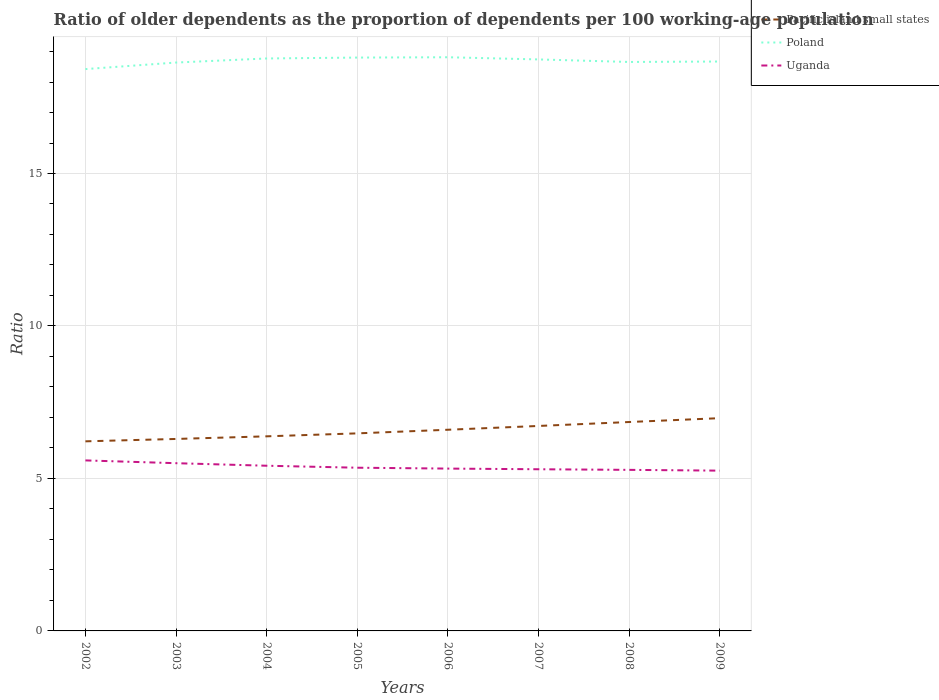How many different coloured lines are there?
Ensure brevity in your answer.  3. Does the line corresponding to Poland intersect with the line corresponding to Uganda?
Make the answer very short. No. Is the number of lines equal to the number of legend labels?
Give a very brief answer. Yes. Across all years, what is the maximum age dependency ratio(old) in Pacific island small states?
Offer a terse response. 6.22. What is the total age dependency ratio(old) in Pacific island small states in the graph?
Your answer should be compact. -0.76. What is the difference between the highest and the second highest age dependency ratio(old) in Pacific island small states?
Keep it short and to the point. 0.76. What is the difference between the highest and the lowest age dependency ratio(old) in Pacific island small states?
Provide a short and direct response. 4. How many lines are there?
Your answer should be compact. 3. How many years are there in the graph?
Your answer should be compact. 8. Are the values on the major ticks of Y-axis written in scientific E-notation?
Your response must be concise. No. Where does the legend appear in the graph?
Give a very brief answer. Top right. How many legend labels are there?
Keep it short and to the point. 3. How are the legend labels stacked?
Give a very brief answer. Vertical. What is the title of the graph?
Your answer should be very brief. Ratio of older dependents as the proportion of dependents per 100 working-age population. What is the label or title of the X-axis?
Your response must be concise. Years. What is the label or title of the Y-axis?
Give a very brief answer. Ratio. What is the Ratio in Pacific island small states in 2002?
Your answer should be compact. 6.22. What is the Ratio in Poland in 2002?
Provide a short and direct response. 18.42. What is the Ratio of Uganda in 2002?
Make the answer very short. 5.59. What is the Ratio of Pacific island small states in 2003?
Offer a very short reply. 6.3. What is the Ratio of Poland in 2003?
Keep it short and to the point. 18.64. What is the Ratio in Uganda in 2003?
Offer a terse response. 5.5. What is the Ratio in Pacific island small states in 2004?
Your answer should be very brief. 6.38. What is the Ratio of Poland in 2004?
Provide a short and direct response. 18.77. What is the Ratio in Uganda in 2004?
Your answer should be compact. 5.42. What is the Ratio of Pacific island small states in 2005?
Keep it short and to the point. 6.48. What is the Ratio of Poland in 2005?
Offer a terse response. 18.8. What is the Ratio of Uganda in 2005?
Keep it short and to the point. 5.35. What is the Ratio of Pacific island small states in 2006?
Your response must be concise. 6.6. What is the Ratio in Poland in 2006?
Ensure brevity in your answer.  18.81. What is the Ratio of Uganda in 2006?
Provide a succinct answer. 5.32. What is the Ratio in Pacific island small states in 2007?
Your answer should be compact. 6.72. What is the Ratio in Poland in 2007?
Make the answer very short. 18.74. What is the Ratio in Uganda in 2007?
Give a very brief answer. 5.3. What is the Ratio of Pacific island small states in 2008?
Keep it short and to the point. 6.85. What is the Ratio of Poland in 2008?
Provide a short and direct response. 18.66. What is the Ratio of Uganda in 2008?
Give a very brief answer. 5.28. What is the Ratio of Pacific island small states in 2009?
Your response must be concise. 6.98. What is the Ratio in Poland in 2009?
Keep it short and to the point. 18.67. What is the Ratio of Uganda in 2009?
Give a very brief answer. 5.26. Across all years, what is the maximum Ratio of Pacific island small states?
Offer a terse response. 6.98. Across all years, what is the maximum Ratio of Poland?
Your response must be concise. 18.81. Across all years, what is the maximum Ratio of Uganda?
Provide a succinct answer. 5.59. Across all years, what is the minimum Ratio of Pacific island small states?
Give a very brief answer. 6.22. Across all years, what is the minimum Ratio in Poland?
Your answer should be compact. 18.42. Across all years, what is the minimum Ratio of Uganda?
Give a very brief answer. 5.26. What is the total Ratio of Pacific island small states in the graph?
Your answer should be compact. 52.52. What is the total Ratio of Poland in the graph?
Give a very brief answer. 149.52. What is the total Ratio of Uganda in the graph?
Provide a succinct answer. 43.02. What is the difference between the Ratio of Pacific island small states in 2002 and that in 2003?
Give a very brief answer. -0.08. What is the difference between the Ratio of Poland in 2002 and that in 2003?
Offer a very short reply. -0.21. What is the difference between the Ratio of Uganda in 2002 and that in 2003?
Offer a very short reply. 0.09. What is the difference between the Ratio of Pacific island small states in 2002 and that in 2004?
Offer a very short reply. -0.16. What is the difference between the Ratio of Poland in 2002 and that in 2004?
Your answer should be very brief. -0.35. What is the difference between the Ratio in Uganda in 2002 and that in 2004?
Keep it short and to the point. 0.17. What is the difference between the Ratio in Pacific island small states in 2002 and that in 2005?
Ensure brevity in your answer.  -0.26. What is the difference between the Ratio in Poland in 2002 and that in 2005?
Keep it short and to the point. -0.38. What is the difference between the Ratio in Uganda in 2002 and that in 2005?
Your answer should be very brief. 0.24. What is the difference between the Ratio of Pacific island small states in 2002 and that in 2006?
Your answer should be compact. -0.38. What is the difference between the Ratio of Poland in 2002 and that in 2006?
Your response must be concise. -0.39. What is the difference between the Ratio in Uganda in 2002 and that in 2006?
Your response must be concise. 0.27. What is the difference between the Ratio of Pacific island small states in 2002 and that in 2007?
Provide a short and direct response. -0.5. What is the difference between the Ratio of Poland in 2002 and that in 2007?
Ensure brevity in your answer.  -0.32. What is the difference between the Ratio of Uganda in 2002 and that in 2007?
Keep it short and to the point. 0.29. What is the difference between the Ratio in Pacific island small states in 2002 and that in 2008?
Provide a short and direct response. -0.63. What is the difference between the Ratio of Poland in 2002 and that in 2008?
Provide a succinct answer. -0.23. What is the difference between the Ratio of Uganda in 2002 and that in 2008?
Keep it short and to the point. 0.31. What is the difference between the Ratio of Pacific island small states in 2002 and that in 2009?
Offer a very short reply. -0.76. What is the difference between the Ratio in Poland in 2002 and that in 2009?
Your answer should be compact. -0.25. What is the difference between the Ratio of Uganda in 2002 and that in 2009?
Your answer should be very brief. 0.34. What is the difference between the Ratio in Pacific island small states in 2003 and that in 2004?
Offer a very short reply. -0.09. What is the difference between the Ratio in Poland in 2003 and that in 2004?
Offer a terse response. -0.13. What is the difference between the Ratio of Uganda in 2003 and that in 2004?
Your answer should be very brief. 0.08. What is the difference between the Ratio of Pacific island small states in 2003 and that in 2005?
Your response must be concise. -0.18. What is the difference between the Ratio in Poland in 2003 and that in 2005?
Ensure brevity in your answer.  -0.16. What is the difference between the Ratio in Uganda in 2003 and that in 2005?
Provide a succinct answer. 0.15. What is the difference between the Ratio of Pacific island small states in 2003 and that in 2006?
Provide a short and direct response. -0.3. What is the difference between the Ratio in Poland in 2003 and that in 2006?
Ensure brevity in your answer.  -0.17. What is the difference between the Ratio in Uganda in 2003 and that in 2006?
Provide a succinct answer. 0.18. What is the difference between the Ratio in Pacific island small states in 2003 and that in 2007?
Offer a very short reply. -0.43. What is the difference between the Ratio in Poland in 2003 and that in 2007?
Give a very brief answer. -0.1. What is the difference between the Ratio in Uganda in 2003 and that in 2007?
Offer a terse response. 0.2. What is the difference between the Ratio of Pacific island small states in 2003 and that in 2008?
Keep it short and to the point. -0.55. What is the difference between the Ratio in Poland in 2003 and that in 2008?
Keep it short and to the point. -0.02. What is the difference between the Ratio in Uganda in 2003 and that in 2008?
Your answer should be compact. 0.22. What is the difference between the Ratio in Pacific island small states in 2003 and that in 2009?
Provide a short and direct response. -0.68. What is the difference between the Ratio of Poland in 2003 and that in 2009?
Make the answer very short. -0.03. What is the difference between the Ratio in Uganda in 2003 and that in 2009?
Offer a terse response. 0.24. What is the difference between the Ratio of Pacific island small states in 2004 and that in 2005?
Provide a short and direct response. -0.1. What is the difference between the Ratio of Poland in 2004 and that in 2005?
Make the answer very short. -0.03. What is the difference between the Ratio in Uganda in 2004 and that in 2005?
Offer a terse response. 0.06. What is the difference between the Ratio of Pacific island small states in 2004 and that in 2006?
Give a very brief answer. -0.22. What is the difference between the Ratio in Poland in 2004 and that in 2006?
Keep it short and to the point. -0.04. What is the difference between the Ratio in Uganda in 2004 and that in 2006?
Offer a very short reply. 0.09. What is the difference between the Ratio of Pacific island small states in 2004 and that in 2007?
Offer a terse response. -0.34. What is the difference between the Ratio of Poland in 2004 and that in 2007?
Your answer should be very brief. 0.03. What is the difference between the Ratio in Uganda in 2004 and that in 2007?
Your answer should be very brief. 0.12. What is the difference between the Ratio in Pacific island small states in 2004 and that in 2008?
Offer a terse response. -0.47. What is the difference between the Ratio of Poland in 2004 and that in 2008?
Offer a terse response. 0.11. What is the difference between the Ratio of Uganda in 2004 and that in 2008?
Provide a succinct answer. 0.14. What is the difference between the Ratio in Pacific island small states in 2004 and that in 2009?
Offer a terse response. -0.6. What is the difference between the Ratio of Poland in 2004 and that in 2009?
Offer a terse response. 0.1. What is the difference between the Ratio in Uganda in 2004 and that in 2009?
Provide a short and direct response. 0.16. What is the difference between the Ratio of Pacific island small states in 2005 and that in 2006?
Offer a very short reply. -0.12. What is the difference between the Ratio in Poland in 2005 and that in 2006?
Your answer should be very brief. -0.01. What is the difference between the Ratio of Uganda in 2005 and that in 2006?
Your response must be concise. 0.03. What is the difference between the Ratio of Pacific island small states in 2005 and that in 2007?
Your answer should be very brief. -0.24. What is the difference between the Ratio in Poland in 2005 and that in 2007?
Ensure brevity in your answer.  0.06. What is the difference between the Ratio in Uganda in 2005 and that in 2007?
Offer a very short reply. 0.05. What is the difference between the Ratio of Pacific island small states in 2005 and that in 2008?
Offer a very short reply. -0.37. What is the difference between the Ratio of Poland in 2005 and that in 2008?
Give a very brief answer. 0.14. What is the difference between the Ratio of Uganda in 2005 and that in 2008?
Give a very brief answer. 0.07. What is the difference between the Ratio of Pacific island small states in 2005 and that in 2009?
Provide a succinct answer. -0.5. What is the difference between the Ratio of Poland in 2005 and that in 2009?
Provide a short and direct response. 0.13. What is the difference between the Ratio of Uganda in 2005 and that in 2009?
Provide a succinct answer. 0.1. What is the difference between the Ratio in Pacific island small states in 2006 and that in 2007?
Provide a succinct answer. -0.12. What is the difference between the Ratio of Poland in 2006 and that in 2007?
Give a very brief answer. 0.07. What is the difference between the Ratio in Uganda in 2006 and that in 2007?
Your answer should be very brief. 0.02. What is the difference between the Ratio of Pacific island small states in 2006 and that in 2008?
Make the answer very short. -0.25. What is the difference between the Ratio in Poland in 2006 and that in 2008?
Provide a succinct answer. 0.15. What is the difference between the Ratio in Uganda in 2006 and that in 2008?
Provide a succinct answer. 0.04. What is the difference between the Ratio in Pacific island small states in 2006 and that in 2009?
Provide a short and direct response. -0.38. What is the difference between the Ratio of Poland in 2006 and that in 2009?
Provide a short and direct response. 0.14. What is the difference between the Ratio of Uganda in 2006 and that in 2009?
Ensure brevity in your answer.  0.07. What is the difference between the Ratio in Pacific island small states in 2007 and that in 2008?
Your answer should be compact. -0.13. What is the difference between the Ratio in Poland in 2007 and that in 2008?
Your answer should be compact. 0.08. What is the difference between the Ratio of Pacific island small states in 2007 and that in 2009?
Keep it short and to the point. -0.26. What is the difference between the Ratio of Poland in 2007 and that in 2009?
Ensure brevity in your answer.  0.07. What is the difference between the Ratio in Uganda in 2007 and that in 2009?
Your answer should be compact. 0.05. What is the difference between the Ratio of Pacific island small states in 2008 and that in 2009?
Give a very brief answer. -0.13. What is the difference between the Ratio of Poland in 2008 and that in 2009?
Keep it short and to the point. -0.01. What is the difference between the Ratio in Uganda in 2008 and that in 2009?
Keep it short and to the point. 0.03. What is the difference between the Ratio in Pacific island small states in 2002 and the Ratio in Poland in 2003?
Your answer should be compact. -12.42. What is the difference between the Ratio in Pacific island small states in 2002 and the Ratio in Uganda in 2003?
Your response must be concise. 0.72. What is the difference between the Ratio of Poland in 2002 and the Ratio of Uganda in 2003?
Your response must be concise. 12.92. What is the difference between the Ratio of Pacific island small states in 2002 and the Ratio of Poland in 2004?
Keep it short and to the point. -12.55. What is the difference between the Ratio of Pacific island small states in 2002 and the Ratio of Uganda in 2004?
Your answer should be very brief. 0.8. What is the difference between the Ratio of Poland in 2002 and the Ratio of Uganda in 2004?
Keep it short and to the point. 13.01. What is the difference between the Ratio of Pacific island small states in 2002 and the Ratio of Poland in 2005?
Your response must be concise. -12.58. What is the difference between the Ratio of Pacific island small states in 2002 and the Ratio of Uganda in 2005?
Ensure brevity in your answer.  0.87. What is the difference between the Ratio of Poland in 2002 and the Ratio of Uganda in 2005?
Your response must be concise. 13.07. What is the difference between the Ratio of Pacific island small states in 2002 and the Ratio of Poland in 2006?
Your answer should be compact. -12.6. What is the difference between the Ratio of Pacific island small states in 2002 and the Ratio of Uganda in 2006?
Your answer should be very brief. 0.89. What is the difference between the Ratio of Poland in 2002 and the Ratio of Uganda in 2006?
Keep it short and to the point. 13.1. What is the difference between the Ratio in Pacific island small states in 2002 and the Ratio in Poland in 2007?
Give a very brief answer. -12.52. What is the difference between the Ratio in Pacific island small states in 2002 and the Ratio in Uganda in 2007?
Make the answer very short. 0.92. What is the difference between the Ratio of Poland in 2002 and the Ratio of Uganda in 2007?
Keep it short and to the point. 13.12. What is the difference between the Ratio of Pacific island small states in 2002 and the Ratio of Poland in 2008?
Offer a very short reply. -12.44. What is the difference between the Ratio in Pacific island small states in 2002 and the Ratio in Uganda in 2008?
Keep it short and to the point. 0.94. What is the difference between the Ratio in Poland in 2002 and the Ratio in Uganda in 2008?
Make the answer very short. 13.14. What is the difference between the Ratio in Pacific island small states in 2002 and the Ratio in Poland in 2009?
Offer a very short reply. -12.45. What is the difference between the Ratio in Pacific island small states in 2002 and the Ratio in Uganda in 2009?
Make the answer very short. 0.96. What is the difference between the Ratio in Poland in 2002 and the Ratio in Uganda in 2009?
Keep it short and to the point. 13.17. What is the difference between the Ratio of Pacific island small states in 2003 and the Ratio of Poland in 2004?
Keep it short and to the point. -12.48. What is the difference between the Ratio in Pacific island small states in 2003 and the Ratio in Uganda in 2004?
Make the answer very short. 0.88. What is the difference between the Ratio in Poland in 2003 and the Ratio in Uganda in 2004?
Your answer should be very brief. 13.22. What is the difference between the Ratio in Pacific island small states in 2003 and the Ratio in Poland in 2005?
Your answer should be compact. -12.51. What is the difference between the Ratio in Pacific island small states in 2003 and the Ratio in Uganda in 2005?
Keep it short and to the point. 0.94. What is the difference between the Ratio of Poland in 2003 and the Ratio of Uganda in 2005?
Your answer should be very brief. 13.29. What is the difference between the Ratio in Pacific island small states in 2003 and the Ratio in Poland in 2006?
Make the answer very short. -12.52. What is the difference between the Ratio of Pacific island small states in 2003 and the Ratio of Uganda in 2006?
Give a very brief answer. 0.97. What is the difference between the Ratio of Poland in 2003 and the Ratio of Uganda in 2006?
Give a very brief answer. 13.32. What is the difference between the Ratio of Pacific island small states in 2003 and the Ratio of Poland in 2007?
Your answer should be compact. -12.45. What is the difference between the Ratio of Poland in 2003 and the Ratio of Uganda in 2007?
Your answer should be very brief. 13.34. What is the difference between the Ratio of Pacific island small states in 2003 and the Ratio of Poland in 2008?
Your response must be concise. -12.36. What is the difference between the Ratio of Pacific island small states in 2003 and the Ratio of Uganda in 2008?
Provide a short and direct response. 1.01. What is the difference between the Ratio of Poland in 2003 and the Ratio of Uganda in 2008?
Your response must be concise. 13.36. What is the difference between the Ratio in Pacific island small states in 2003 and the Ratio in Poland in 2009?
Provide a succinct answer. -12.38. What is the difference between the Ratio of Pacific island small states in 2003 and the Ratio of Uganda in 2009?
Provide a succinct answer. 1.04. What is the difference between the Ratio of Poland in 2003 and the Ratio of Uganda in 2009?
Give a very brief answer. 13.38. What is the difference between the Ratio in Pacific island small states in 2004 and the Ratio in Poland in 2005?
Ensure brevity in your answer.  -12.42. What is the difference between the Ratio in Pacific island small states in 2004 and the Ratio in Uganda in 2005?
Your answer should be compact. 1.03. What is the difference between the Ratio of Poland in 2004 and the Ratio of Uganda in 2005?
Make the answer very short. 13.42. What is the difference between the Ratio in Pacific island small states in 2004 and the Ratio in Poland in 2006?
Your answer should be compact. -12.43. What is the difference between the Ratio of Pacific island small states in 2004 and the Ratio of Uganda in 2006?
Provide a short and direct response. 1.06. What is the difference between the Ratio in Poland in 2004 and the Ratio in Uganda in 2006?
Offer a very short reply. 13.45. What is the difference between the Ratio of Pacific island small states in 2004 and the Ratio of Poland in 2007?
Make the answer very short. -12.36. What is the difference between the Ratio in Pacific island small states in 2004 and the Ratio in Uganda in 2007?
Your response must be concise. 1.08. What is the difference between the Ratio of Poland in 2004 and the Ratio of Uganda in 2007?
Your response must be concise. 13.47. What is the difference between the Ratio of Pacific island small states in 2004 and the Ratio of Poland in 2008?
Your answer should be very brief. -12.28. What is the difference between the Ratio in Pacific island small states in 2004 and the Ratio in Uganda in 2008?
Provide a short and direct response. 1.1. What is the difference between the Ratio in Poland in 2004 and the Ratio in Uganda in 2008?
Your response must be concise. 13.49. What is the difference between the Ratio in Pacific island small states in 2004 and the Ratio in Poland in 2009?
Offer a terse response. -12.29. What is the difference between the Ratio of Pacific island small states in 2004 and the Ratio of Uganda in 2009?
Keep it short and to the point. 1.13. What is the difference between the Ratio in Poland in 2004 and the Ratio in Uganda in 2009?
Your response must be concise. 13.52. What is the difference between the Ratio in Pacific island small states in 2005 and the Ratio in Poland in 2006?
Your response must be concise. -12.33. What is the difference between the Ratio in Pacific island small states in 2005 and the Ratio in Uganda in 2006?
Make the answer very short. 1.15. What is the difference between the Ratio of Poland in 2005 and the Ratio of Uganda in 2006?
Your response must be concise. 13.48. What is the difference between the Ratio in Pacific island small states in 2005 and the Ratio in Poland in 2007?
Your answer should be compact. -12.26. What is the difference between the Ratio in Pacific island small states in 2005 and the Ratio in Uganda in 2007?
Keep it short and to the point. 1.18. What is the difference between the Ratio in Poland in 2005 and the Ratio in Uganda in 2007?
Your answer should be compact. 13.5. What is the difference between the Ratio of Pacific island small states in 2005 and the Ratio of Poland in 2008?
Provide a succinct answer. -12.18. What is the difference between the Ratio in Pacific island small states in 2005 and the Ratio in Uganda in 2008?
Give a very brief answer. 1.2. What is the difference between the Ratio in Poland in 2005 and the Ratio in Uganda in 2008?
Offer a very short reply. 13.52. What is the difference between the Ratio in Pacific island small states in 2005 and the Ratio in Poland in 2009?
Your answer should be compact. -12.19. What is the difference between the Ratio of Pacific island small states in 2005 and the Ratio of Uganda in 2009?
Keep it short and to the point. 1.22. What is the difference between the Ratio of Poland in 2005 and the Ratio of Uganda in 2009?
Provide a succinct answer. 13.55. What is the difference between the Ratio of Pacific island small states in 2006 and the Ratio of Poland in 2007?
Provide a succinct answer. -12.14. What is the difference between the Ratio of Pacific island small states in 2006 and the Ratio of Uganda in 2007?
Your answer should be very brief. 1.3. What is the difference between the Ratio in Poland in 2006 and the Ratio in Uganda in 2007?
Keep it short and to the point. 13.51. What is the difference between the Ratio of Pacific island small states in 2006 and the Ratio of Poland in 2008?
Your answer should be very brief. -12.06. What is the difference between the Ratio of Pacific island small states in 2006 and the Ratio of Uganda in 2008?
Keep it short and to the point. 1.32. What is the difference between the Ratio of Poland in 2006 and the Ratio of Uganda in 2008?
Offer a terse response. 13.53. What is the difference between the Ratio in Pacific island small states in 2006 and the Ratio in Poland in 2009?
Give a very brief answer. -12.08. What is the difference between the Ratio of Pacific island small states in 2006 and the Ratio of Uganda in 2009?
Provide a short and direct response. 1.34. What is the difference between the Ratio of Poland in 2006 and the Ratio of Uganda in 2009?
Your answer should be very brief. 13.56. What is the difference between the Ratio in Pacific island small states in 2007 and the Ratio in Poland in 2008?
Provide a short and direct response. -11.94. What is the difference between the Ratio in Pacific island small states in 2007 and the Ratio in Uganda in 2008?
Your answer should be compact. 1.44. What is the difference between the Ratio of Poland in 2007 and the Ratio of Uganda in 2008?
Your answer should be very brief. 13.46. What is the difference between the Ratio of Pacific island small states in 2007 and the Ratio of Poland in 2009?
Offer a terse response. -11.95. What is the difference between the Ratio in Pacific island small states in 2007 and the Ratio in Uganda in 2009?
Provide a short and direct response. 1.47. What is the difference between the Ratio of Poland in 2007 and the Ratio of Uganda in 2009?
Your response must be concise. 13.48. What is the difference between the Ratio of Pacific island small states in 2008 and the Ratio of Poland in 2009?
Make the answer very short. -11.82. What is the difference between the Ratio of Pacific island small states in 2008 and the Ratio of Uganda in 2009?
Your answer should be very brief. 1.59. What is the difference between the Ratio in Poland in 2008 and the Ratio in Uganda in 2009?
Provide a short and direct response. 13.4. What is the average Ratio of Pacific island small states per year?
Your answer should be compact. 6.56. What is the average Ratio in Poland per year?
Keep it short and to the point. 18.69. What is the average Ratio of Uganda per year?
Your answer should be compact. 5.38. In the year 2002, what is the difference between the Ratio of Pacific island small states and Ratio of Poland?
Give a very brief answer. -12.21. In the year 2002, what is the difference between the Ratio in Pacific island small states and Ratio in Uganda?
Make the answer very short. 0.63. In the year 2002, what is the difference between the Ratio of Poland and Ratio of Uganda?
Keep it short and to the point. 12.83. In the year 2003, what is the difference between the Ratio of Pacific island small states and Ratio of Poland?
Your response must be concise. -12.34. In the year 2003, what is the difference between the Ratio in Pacific island small states and Ratio in Uganda?
Your response must be concise. 0.8. In the year 2003, what is the difference between the Ratio in Poland and Ratio in Uganda?
Offer a terse response. 13.14. In the year 2004, what is the difference between the Ratio in Pacific island small states and Ratio in Poland?
Your response must be concise. -12.39. In the year 2004, what is the difference between the Ratio in Pacific island small states and Ratio in Uganda?
Provide a succinct answer. 0.96. In the year 2004, what is the difference between the Ratio of Poland and Ratio of Uganda?
Offer a very short reply. 13.36. In the year 2005, what is the difference between the Ratio of Pacific island small states and Ratio of Poland?
Offer a very short reply. -12.32. In the year 2005, what is the difference between the Ratio of Pacific island small states and Ratio of Uganda?
Your answer should be very brief. 1.13. In the year 2005, what is the difference between the Ratio in Poland and Ratio in Uganda?
Provide a short and direct response. 13.45. In the year 2006, what is the difference between the Ratio of Pacific island small states and Ratio of Poland?
Keep it short and to the point. -12.22. In the year 2006, what is the difference between the Ratio of Pacific island small states and Ratio of Uganda?
Your answer should be compact. 1.27. In the year 2006, what is the difference between the Ratio in Poland and Ratio in Uganda?
Make the answer very short. 13.49. In the year 2007, what is the difference between the Ratio in Pacific island small states and Ratio in Poland?
Your answer should be very brief. -12.02. In the year 2007, what is the difference between the Ratio in Pacific island small states and Ratio in Uganda?
Provide a succinct answer. 1.42. In the year 2007, what is the difference between the Ratio of Poland and Ratio of Uganda?
Provide a short and direct response. 13.44. In the year 2008, what is the difference between the Ratio in Pacific island small states and Ratio in Poland?
Your answer should be compact. -11.81. In the year 2008, what is the difference between the Ratio in Pacific island small states and Ratio in Uganda?
Your answer should be very brief. 1.57. In the year 2008, what is the difference between the Ratio of Poland and Ratio of Uganda?
Your response must be concise. 13.38. In the year 2009, what is the difference between the Ratio in Pacific island small states and Ratio in Poland?
Offer a very short reply. -11.7. In the year 2009, what is the difference between the Ratio of Pacific island small states and Ratio of Uganda?
Provide a succinct answer. 1.72. In the year 2009, what is the difference between the Ratio of Poland and Ratio of Uganda?
Your response must be concise. 13.42. What is the ratio of the Ratio of Pacific island small states in 2002 to that in 2003?
Your answer should be compact. 0.99. What is the ratio of the Ratio of Poland in 2002 to that in 2003?
Your answer should be compact. 0.99. What is the ratio of the Ratio in Uganda in 2002 to that in 2003?
Make the answer very short. 1.02. What is the ratio of the Ratio of Pacific island small states in 2002 to that in 2004?
Offer a very short reply. 0.97. What is the ratio of the Ratio of Poland in 2002 to that in 2004?
Keep it short and to the point. 0.98. What is the ratio of the Ratio of Uganda in 2002 to that in 2004?
Your answer should be very brief. 1.03. What is the ratio of the Ratio of Pacific island small states in 2002 to that in 2005?
Give a very brief answer. 0.96. What is the ratio of the Ratio in Poland in 2002 to that in 2005?
Your answer should be very brief. 0.98. What is the ratio of the Ratio of Uganda in 2002 to that in 2005?
Provide a short and direct response. 1.04. What is the ratio of the Ratio in Pacific island small states in 2002 to that in 2006?
Provide a short and direct response. 0.94. What is the ratio of the Ratio in Poland in 2002 to that in 2006?
Your answer should be very brief. 0.98. What is the ratio of the Ratio in Uganda in 2002 to that in 2006?
Offer a terse response. 1.05. What is the ratio of the Ratio of Pacific island small states in 2002 to that in 2007?
Offer a very short reply. 0.93. What is the ratio of the Ratio in Poland in 2002 to that in 2007?
Make the answer very short. 0.98. What is the ratio of the Ratio in Uganda in 2002 to that in 2007?
Provide a succinct answer. 1.05. What is the ratio of the Ratio of Pacific island small states in 2002 to that in 2008?
Give a very brief answer. 0.91. What is the ratio of the Ratio in Poland in 2002 to that in 2008?
Ensure brevity in your answer.  0.99. What is the ratio of the Ratio in Uganda in 2002 to that in 2008?
Your response must be concise. 1.06. What is the ratio of the Ratio in Pacific island small states in 2002 to that in 2009?
Offer a very short reply. 0.89. What is the ratio of the Ratio of Poland in 2002 to that in 2009?
Make the answer very short. 0.99. What is the ratio of the Ratio of Uganda in 2002 to that in 2009?
Offer a very short reply. 1.06. What is the ratio of the Ratio in Pacific island small states in 2003 to that in 2004?
Your answer should be compact. 0.99. What is the ratio of the Ratio in Uganda in 2003 to that in 2004?
Make the answer very short. 1.02. What is the ratio of the Ratio of Pacific island small states in 2003 to that in 2005?
Your response must be concise. 0.97. What is the ratio of the Ratio of Uganda in 2003 to that in 2005?
Your answer should be very brief. 1.03. What is the ratio of the Ratio of Pacific island small states in 2003 to that in 2006?
Your answer should be compact. 0.95. What is the ratio of the Ratio of Uganda in 2003 to that in 2006?
Offer a terse response. 1.03. What is the ratio of the Ratio in Pacific island small states in 2003 to that in 2007?
Offer a terse response. 0.94. What is the ratio of the Ratio in Poland in 2003 to that in 2007?
Provide a short and direct response. 0.99. What is the ratio of the Ratio of Uganda in 2003 to that in 2007?
Provide a short and direct response. 1.04. What is the ratio of the Ratio in Pacific island small states in 2003 to that in 2008?
Offer a very short reply. 0.92. What is the ratio of the Ratio in Uganda in 2003 to that in 2008?
Offer a terse response. 1.04. What is the ratio of the Ratio in Pacific island small states in 2003 to that in 2009?
Provide a short and direct response. 0.9. What is the ratio of the Ratio of Poland in 2003 to that in 2009?
Give a very brief answer. 1. What is the ratio of the Ratio in Uganda in 2003 to that in 2009?
Make the answer very short. 1.05. What is the ratio of the Ratio in Poland in 2004 to that in 2005?
Make the answer very short. 1. What is the ratio of the Ratio in Uganda in 2004 to that in 2005?
Your answer should be very brief. 1.01. What is the ratio of the Ratio in Pacific island small states in 2004 to that in 2006?
Offer a terse response. 0.97. What is the ratio of the Ratio in Poland in 2004 to that in 2006?
Provide a succinct answer. 1. What is the ratio of the Ratio of Uganda in 2004 to that in 2006?
Ensure brevity in your answer.  1.02. What is the ratio of the Ratio in Pacific island small states in 2004 to that in 2007?
Offer a very short reply. 0.95. What is the ratio of the Ratio in Poland in 2004 to that in 2007?
Offer a very short reply. 1. What is the ratio of the Ratio in Uganda in 2004 to that in 2007?
Give a very brief answer. 1.02. What is the ratio of the Ratio in Pacific island small states in 2004 to that in 2008?
Your answer should be very brief. 0.93. What is the ratio of the Ratio of Uganda in 2004 to that in 2008?
Your response must be concise. 1.03. What is the ratio of the Ratio in Pacific island small states in 2004 to that in 2009?
Provide a short and direct response. 0.91. What is the ratio of the Ratio of Poland in 2004 to that in 2009?
Provide a short and direct response. 1.01. What is the ratio of the Ratio in Uganda in 2004 to that in 2009?
Provide a succinct answer. 1.03. What is the ratio of the Ratio of Pacific island small states in 2005 to that in 2006?
Provide a short and direct response. 0.98. What is the ratio of the Ratio of Poland in 2005 to that in 2006?
Offer a terse response. 1. What is the ratio of the Ratio of Uganda in 2005 to that in 2006?
Provide a succinct answer. 1.01. What is the ratio of the Ratio in Pacific island small states in 2005 to that in 2007?
Make the answer very short. 0.96. What is the ratio of the Ratio in Uganda in 2005 to that in 2007?
Your answer should be very brief. 1.01. What is the ratio of the Ratio of Pacific island small states in 2005 to that in 2008?
Make the answer very short. 0.95. What is the ratio of the Ratio of Poland in 2005 to that in 2008?
Your answer should be very brief. 1.01. What is the ratio of the Ratio of Uganda in 2005 to that in 2008?
Provide a succinct answer. 1.01. What is the ratio of the Ratio in Pacific island small states in 2005 to that in 2009?
Give a very brief answer. 0.93. What is the ratio of the Ratio of Poland in 2005 to that in 2009?
Your response must be concise. 1.01. What is the ratio of the Ratio of Uganda in 2005 to that in 2009?
Your answer should be compact. 1.02. What is the ratio of the Ratio in Pacific island small states in 2006 to that in 2007?
Keep it short and to the point. 0.98. What is the ratio of the Ratio in Uganda in 2006 to that in 2007?
Offer a terse response. 1. What is the ratio of the Ratio of Pacific island small states in 2006 to that in 2008?
Give a very brief answer. 0.96. What is the ratio of the Ratio in Poland in 2006 to that in 2008?
Provide a short and direct response. 1.01. What is the ratio of the Ratio in Uganda in 2006 to that in 2008?
Offer a very short reply. 1.01. What is the ratio of the Ratio of Pacific island small states in 2006 to that in 2009?
Your answer should be compact. 0.95. What is the ratio of the Ratio in Poland in 2006 to that in 2009?
Keep it short and to the point. 1.01. What is the ratio of the Ratio in Uganda in 2006 to that in 2009?
Your response must be concise. 1.01. What is the ratio of the Ratio in Pacific island small states in 2007 to that in 2008?
Your answer should be compact. 0.98. What is the ratio of the Ratio in Pacific island small states in 2007 to that in 2009?
Provide a succinct answer. 0.96. What is the ratio of the Ratio in Uganda in 2007 to that in 2009?
Offer a very short reply. 1.01. What is the ratio of the Ratio in Pacific island small states in 2008 to that in 2009?
Keep it short and to the point. 0.98. What is the ratio of the Ratio of Poland in 2008 to that in 2009?
Offer a terse response. 1. What is the difference between the highest and the second highest Ratio in Pacific island small states?
Provide a succinct answer. 0.13. What is the difference between the highest and the second highest Ratio in Poland?
Your answer should be compact. 0.01. What is the difference between the highest and the second highest Ratio in Uganda?
Provide a succinct answer. 0.09. What is the difference between the highest and the lowest Ratio in Pacific island small states?
Make the answer very short. 0.76. What is the difference between the highest and the lowest Ratio in Poland?
Ensure brevity in your answer.  0.39. What is the difference between the highest and the lowest Ratio in Uganda?
Your response must be concise. 0.34. 